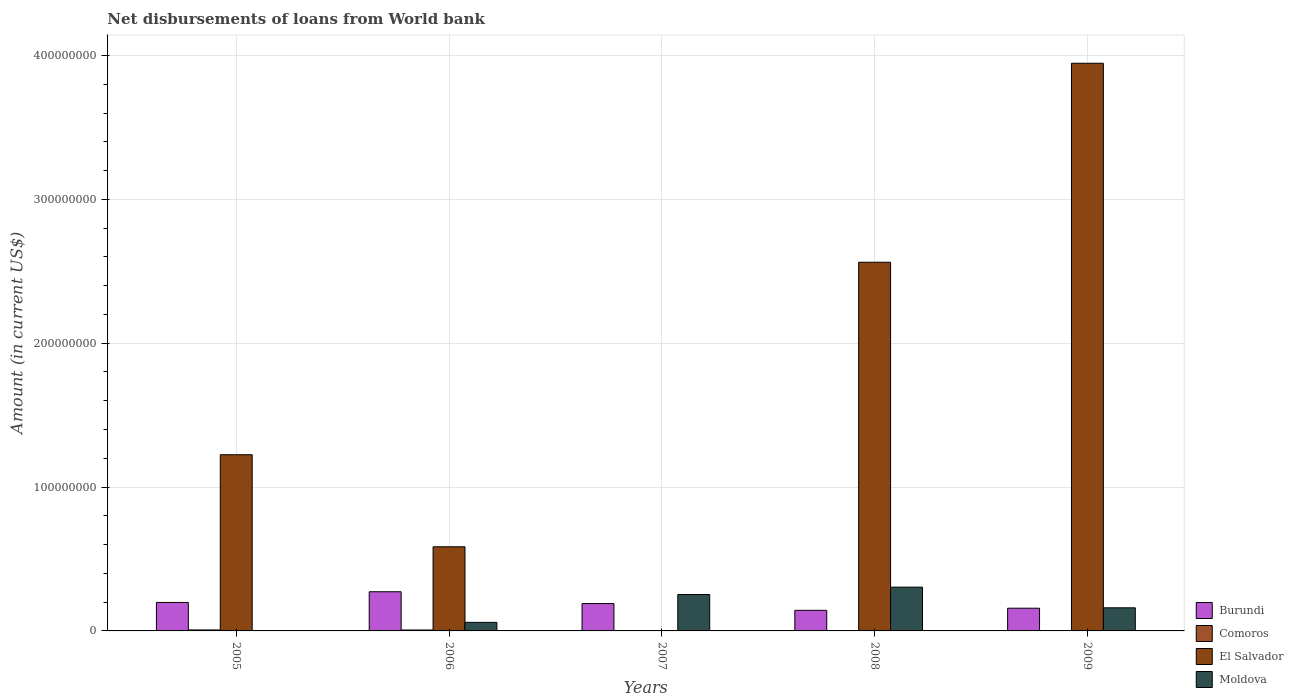How many different coloured bars are there?
Offer a very short reply. 4. Are the number of bars per tick equal to the number of legend labels?
Provide a succinct answer. No. Are the number of bars on each tick of the X-axis equal?
Provide a succinct answer. No. How many bars are there on the 3rd tick from the left?
Your answer should be compact. 2. How many bars are there on the 1st tick from the right?
Ensure brevity in your answer.  3. What is the amount of loan disbursed from World Bank in Comoros in 2006?
Provide a short and direct response. 6.45e+05. Across all years, what is the maximum amount of loan disbursed from World Bank in Comoros?
Offer a very short reply. 6.81e+05. What is the total amount of loan disbursed from World Bank in Comoros in the graph?
Offer a very short reply. 1.33e+06. What is the difference between the amount of loan disbursed from World Bank in Burundi in 2008 and that in 2009?
Your answer should be very brief. -1.48e+06. What is the difference between the amount of loan disbursed from World Bank in Moldova in 2008 and the amount of loan disbursed from World Bank in Burundi in 2007?
Give a very brief answer. 1.14e+07. What is the average amount of loan disbursed from World Bank in Burundi per year?
Keep it short and to the point. 1.92e+07. In the year 2006, what is the difference between the amount of loan disbursed from World Bank in El Salvador and amount of loan disbursed from World Bank in Burundi?
Provide a short and direct response. 3.13e+07. What is the ratio of the amount of loan disbursed from World Bank in Burundi in 2008 to that in 2009?
Provide a short and direct response. 0.91. Is the amount of loan disbursed from World Bank in Burundi in 2008 less than that in 2009?
Your response must be concise. Yes. What is the difference between the highest and the second highest amount of loan disbursed from World Bank in Moldova?
Keep it short and to the point. 5.12e+06. What is the difference between the highest and the lowest amount of loan disbursed from World Bank in Comoros?
Keep it short and to the point. 6.81e+05. Is it the case that in every year, the sum of the amount of loan disbursed from World Bank in El Salvador and amount of loan disbursed from World Bank in Comoros is greater than the sum of amount of loan disbursed from World Bank in Burundi and amount of loan disbursed from World Bank in Moldova?
Offer a terse response. No. Is it the case that in every year, the sum of the amount of loan disbursed from World Bank in Comoros and amount of loan disbursed from World Bank in Burundi is greater than the amount of loan disbursed from World Bank in El Salvador?
Make the answer very short. No. How many bars are there?
Ensure brevity in your answer.  15. Are all the bars in the graph horizontal?
Make the answer very short. No. What is the difference between two consecutive major ticks on the Y-axis?
Make the answer very short. 1.00e+08. Where does the legend appear in the graph?
Ensure brevity in your answer.  Bottom right. What is the title of the graph?
Keep it short and to the point. Net disbursements of loans from World bank. Does "Sweden" appear as one of the legend labels in the graph?
Your answer should be very brief. No. What is the label or title of the Y-axis?
Provide a succinct answer. Amount (in current US$). What is the Amount (in current US$) in Burundi in 2005?
Give a very brief answer. 1.98e+07. What is the Amount (in current US$) of Comoros in 2005?
Your answer should be compact. 6.81e+05. What is the Amount (in current US$) of El Salvador in 2005?
Your response must be concise. 1.22e+08. What is the Amount (in current US$) of Burundi in 2006?
Offer a terse response. 2.72e+07. What is the Amount (in current US$) of Comoros in 2006?
Provide a short and direct response. 6.45e+05. What is the Amount (in current US$) in El Salvador in 2006?
Offer a very short reply. 5.85e+07. What is the Amount (in current US$) in Moldova in 2006?
Ensure brevity in your answer.  5.95e+06. What is the Amount (in current US$) of Burundi in 2007?
Your answer should be compact. 1.90e+07. What is the Amount (in current US$) of El Salvador in 2007?
Give a very brief answer. 0. What is the Amount (in current US$) in Moldova in 2007?
Your response must be concise. 2.53e+07. What is the Amount (in current US$) of Burundi in 2008?
Offer a very short reply. 1.43e+07. What is the Amount (in current US$) of Comoros in 2008?
Offer a terse response. 0. What is the Amount (in current US$) in El Salvador in 2008?
Your response must be concise. 2.56e+08. What is the Amount (in current US$) in Moldova in 2008?
Ensure brevity in your answer.  3.04e+07. What is the Amount (in current US$) of Burundi in 2009?
Make the answer very short. 1.58e+07. What is the Amount (in current US$) of El Salvador in 2009?
Your response must be concise. 3.95e+08. What is the Amount (in current US$) of Moldova in 2009?
Offer a terse response. 1.61e+07. Across all years, what is the maximum Amount (in current US$) of Burundi?
Your answer should be very brief. 2.72e+07. Across all years, what is the maximum Amount (in current US$) of Comoros?
Give a very brief answer. 6.81e+05. Across all years, what is the maximum Amount (in current US$) in El Salvador?
Provide a succinct answer. 3.95e+08. Across all years, what is the maximum Amount (in current US$) in Moldova?
Ensure brevity in your answer.  3.04e+07. Across all years, what is the minimum Amount (in current US$) of Burundi?
Keep it short and to the point. 1.43e+07. Across all years, what is the minimum Amount (in current US$) in Comoros?
Provide a short and direct response. 0. Across all years, what is the minimum Amount (in current US$) of El Salvador?
Keep it short and to the point. 0. What is the total Amount (in current US$) in Burundi in the graph?
Offer a terse response. 9.61e+07. What is the total Amount (in current US$) in Comoros in the graph?
Provide a short and direct response. 1.33e+06. What is the total Amount (in current US$) in El Salvador in the graph?
Ensure brevity in your answer.  8.32e+08. What is the total Amount (in current US$) of Moldova in the graph?
Make the answer very short. 7.78e+07. What is the difference between the Amount (in current US$) of Burundi in 2005 and that in 2006?
Offer a terse response. -7.45e+06. What is the difference between the Amount (in current US$) in Comoros in 2005 and that in 2006?
Give a very brief answer. 3.60e+04. What is the difference between the Amount (in current US$) in El Salvador in 2005 and that in 2006?
Your answer should be compact. 6.40e+07. What is the difference between the Amount (in current US$) in Burundi in 2005 and that in 2007?
Make the answer very short. 7.64e+05. What is the difference between the Amount (in current US$) in Burundi in 2005 and that in 2008?
Your answer should be very brief. 5.48e+06. What is the difference between the Amount (in current US$) in El Salvador in 2005 and that in 2008?
Keep it short and to the point. -1.34e+08. What is the difference between the Amount (in current US$) of Burundi in 2005 and that in 2009?
Offer a very short reply. 4.00e+06. What is the difference between the Amount (in current US$) of El Salvador in 2005 and that in 2009?
Provide a succinct answer. -2.72e+08. What is the difference between the Amount (in current US$) in Burundi in 2006 and that in 2007?
Your answer should be very brief. 8.21e+06. What is the difference between the Amount (in current US$) of Moldova in 2006 and that in 2007?
Keep it short and to the point. -1.94e+07. What is the difference between the Amount (in current US$) in Burundi in 2006 and that in 2008?
Your answer should be compact. 1.29e+07. What is the difference between the Amount (in current US$) in El Salvador in 2006 and that in 2008?
Offer a terse response. -1.98e+08. What is the difference between the Amount (in current US$) in Moldova in 2006 and that in 2008?
Provide a succinct answer. -2.45e+07. What is the difference between the Amount (in current US$) in Burundi in 2006 and that in 2009?
Your answer should be very brief. 1.14e+07. What is the difference between the Amount (in current US$) of El Salvador in 2006 and that in 2009?
Your answer should be very brief. -3.36e+08. What is the difference between the Amount (in current US$) of Moldova in 2006 and that in 2009?
Give a very brief answer. -1.01e+07. What is the difference between the Amount (in current US$) of Burundi in 2007 and that in 2008?
Offer a terse response. 4.72e+06. What is the difference between the Amount (in current US$) of Moldova in 2007 and that in 2008?
Your response must be concise. -5.12e+06. What is the difference between the Amount (in current US$) of Burundi in 2007 and that in 2009?
Provide a short and direct response. 3.24e+06. What is the difference between the Amount (in current US$) of Moldova in 2007 and that in 2009?
Make the answer very short. 9.24e+06. What is the difference between the Amount (in current US$) in Burundi in 2008 and that in 2009?
Offer a terse response. -1.48e+06. What is the difference between the Amount (in current US$) of El Salvador in 2008 and that in 2009?
Your answer should be compact. -1.38e+08. What is the difference between the Amount (in current US$) in Moldova in 2008 and that in 2009?
Your answer should be compact. 1.44e+07. What is the difference between the Amount (in current US$) in Burundi in 2005 and the Amount (in current US$) in Comoros in 2006?
Ensure brevity in your answer.  1.91e+07. What is the difference between the Amount (in current US$) in Burundi in 2005 and the Amount (in current US$) in El Salvador in 2006?
Make the answer very short. -3.87e+07. What is the difference between the Amount (in current US$) of Burundi in 2005 and the Amount (in current US$) of Moldova in 2006?
Give a very brief answer. 1.38e+07. What is the difference between the Amount (in current US$) of Comoros in 2005 and the Amount (in current US$) of El Salvador in 2006?
Ensure brevity in your answer.  -5.78e+07. What is the difference between the Amount (in current US$) in Comoros in 2005 and the Amount (in current US$) in Moldova in 2006?
Offer a terse response. -5.27e+06. What is the difference between the Amount (in current US$) of El Salvador in 2005 and the Amount (in current US$) of Moldova in 2006?
Your response must be concise. 1.17e+08. What is the difference between the Amount (in current US$) of Burundi in 2005 and the Amount (in current US$) of Moldova in 2007?
Give a very brief answer. -5.52e+06. What is the difference between the Amount (in current US$) in Comoros in 2005 and the Amount (in current US$) in Moldova in 2007?
Offer a very short reply. -2.46e+07. What is the difference between the Amount (in current US$) of El Salvador in 2005 and the Amount (in current US$) of Moldova in 2007?
Provide a succinct answer. 9.72e+07. What is the difference between the Amount (in current US$) of Burundi in 2005 and the Amount (in current US$) of El Salvador in 2008?
Make the answer very short. -2.36e+08. What is the difference between the Amount (in current US$) of Burundi in 2005 and the Amount (in current US$) of Moldova in 2008?
Provide a short and direct response. -1.06e+07. What is the difference between the Amount (in current US$) of Comoros in 2005 and the Amount (in current US$) of El Salvador in 2008?
Keep it short and to the point. -2.56e+08. What is the difference between the Amount (in current US$) of Comoros in 2005 and the Amount (in current US$) of Moldova in 2008?
Give a very brief answer. -2.97e+07. What is the difference between the Amount (in current US$) of El Salvador in 2005 and the Amount (in current US$) of Moldova in 2008?
Provide a succinct answer. 9.21e+07. What is the difference between the Amount (in current US$) in Burundi in 2005 and the Amount (in current US$) in El Salvador in 2009?
Give a very brief answer. -3.75e+08. What is the difference between the Amount (in current US$) in Burundi in 2005 and the Amount (in current US$) in Moldova in 2009?
Offer a very short reply. 3.72e+06. What is the difference between the Amount (in current US$) in Comoros in 2005 and the Amount (in current US$) in El Salvador in 2009?
Keep it short and to the point. -3.94e+08. What is the difference between the Amount (in current US$) of Comoros in 2005 and the Amount (in current US$) of Moldova in 2009?
Offer a terse response. -1.54e+07. What is the difference between the Amount (in current US$) of El Salvador in 2005 and the Amount (in current US$) of Moldova in 2009?
Ensure brevity in your answer.  1.06e+08. What is the difference between the Amount (in current US$) of Burundi in 2006 and the Amount (in current US$) of Moldova in 2007?
Your answer should be compact. 1.92e+06. What is the difference between the Amount (in current US$) in Comoros in 2006 and the Amount (in current US$) in Moldova in 2007?
Ensure brevity in your answer.  -2.47e+07. What is the difference between the Amount (in current US$) in El Salvador in 2006 and the Amount (in current US$) in Moldova in 2007?
Ensure brevity in your answer.  3.32e+07. What is the difference between the Amount (in current US$) of Burundi in 2006 and the Amount (in current US$) of El Salvador in 2008?
Your response must be concise. -2.29e+08. What is the difference between the Amount (in current US$) of Burundi in 2006 and the Amount (in current US$) of Moldova in 2008?
Offer a very short reply. -3.19e+06. What is the difference between the Amount (in current US$) of Comoros in 2006 and the Amount (in current US$) of El Salvador in 2008?
Your answer should be very brief. -2.56e+08. What is the difference between the Amount (in current US$) of Comoros in 2006 and the Amount (in current US$) of Moldova in 2008?
Ensure brevity in your answer.  -2.98e+07. What is the difference between the Amount (in current US$) of El Salvador in 2006 and the Amount (in current US$) of Moldova in 2008?
Ensure brevity in your answer.  2.81e+07. What is the difference between the Amount (in current US$) of Burundi in 2006 and the Amount (in current US$) of El Salvador in 2009?
Your response must be concise. -3.67e+08. What is the difference between the Amount (in current US$) of Burundi in 2006 and the Amount (in current US$) of Moldova in 2009?
Keep it short and to the point. 1.12e+07. What is the difference between the Amount (in current US$) in Comoros in 2006 and the Amount (in current US$) in El Salvador in 2009?
Keep it short and to the point. -3.94e+08. What is the difference between the Amount (in current US$) of Comoros in 2006 and the Amount (in current US$) of Moldova in 2009?
Your answer should be very brief. -1.54e+07. What is the difference between the Amount (in current US$) of El Salvador in 2006 and the Amount (in current US$) of Moldova in 2009?
Your response must be concise. 4.24e+07. What is the difference between the Amount (in current US$) of Burundi in 2007 and the Amount (in current US$) of El Salvador in 2008?
Ensure brevity in your answer.  -2.37e+08. What is the difference between the Amount (in current US$) of Burundi in 2007 and the Amount (in current US$) of Moldova in 2008?
Provide a succinct answer. -1.14e+07. What is the difference between the Amount (in current US$) of Burundi in 2007 and the Amount (in current US$) of El Salvador in 2009?
Your answer should be very brief. -3.76e+08. What is the difference between the Amount (in current US$) of Burundi in 2007 and the Amount (in current US$) of Moldova in 2009?
Ensure brevity in your answer.  2.96e+06. What is the difference between the Amount (in current US$) in Burundi in 2008 and the Amount (in current US$) in El Salvador in 2009?
Your answer should be compact. -3.80e+08. What is the difference between the Amount (in current US$) of Burundi in 2008 and the Amount (in current US$) of Moldova in 2009?
Your answer should be compact. -1.76e+06. What is the difference between the Amount (in current US$) of El Salvador in 2008 and the Amount (in current US$) of Moldova in 2009?
Your answer should be compact. 2.40e+08. What is the average Amount (in current US$) of Burundi per year?
Ensure brevity in your answer.  1.92e+07. What is the average Amount (in current US$) of Comoros per year?
Your response must be concise. 2.65e+05. What is the average Amount (in current US$) in El Salvador per year?
Offer a very short reply. 1.66e+08. What is the average Amount (in current US$) of Moldova per year?
Keep it short and to the point. 1.56e+07. In the year 2005, what is the difference between the Amount (in current US$) in Burundi and Amount (in current US$) in Comoros?
Provide a succinct answer. 1.91e+07. In the year 2005, what is the difference between the Amount (in current US$) of Burundi and Amount (in current US$) of El Salvador?
Provide a short and direct response. -1.03e+08. In the year 2005, what is the difference between the Amount (in current US$) of Comoros and Amount (in current US$) of El Salvador?
Your answer should be compact. -1.22e+08. In the year 2006, what is the difference between the Amount (in current US$) of Burundi and Amount (in current US$) of Comoros?
Your response must be concise. 2.66e+07. In the year 2006, what is the difference between the Amount (in current US$) of Burundi and Amount (in current US$) of El Salvador?
Make the answer very short. -3.13e+07. In the year 2006, what is the difference between the Amount (in current US$) of Burundi and Amount (in current US$) of Moldova?
Provide a short and direct response. 2.13e+07. In the year 2006, what is the difference between the Amount (in current US$) of Comoros and Amount (in current US$) of El Salvador?
Make the answer very short. -5.78e+07. In the year 2006, what is the difference between the Amount (in current US$) in Comoros and Amount (in current US$) in Moldova?
Offer a terse response. -5.31e+06. In the year 2006, what is the difference between the Amount (in current US$) in El Salvador and Amount (in current US$) in Moldova?
Your response must be concise. 5.25e+07. In the year 2007, what is the difference between the Amount (in current US$) of Burundi and Amount (in current US$) of Moldova?
Make the answer very short. -6.29e+06. In the year 2008, what is the difference between the Amount (in current US$) in Burundi and Amount (in current US$) in El Salvador?
Your response must be concise. -2.42e+08. In the year 2008, what is the difference between the Amount (in current US$) in Burundi and Amount (in current US$) in Moldova?
Offer a terse response. -1.61e+07. In the year 2008, what is the difference between the Amount (in current US$) in El Salvador and Amount (in current US$) in Moldova?
Ensure brevity in your answer.  2.26e+08. In the year 2009, what is the difference between the Amount (in current US$) of Burundi and Amount (in current US$) of El Salvador?
Provide a succinct answer. -3.79e+08. In the year 2009, what is the difference between the Amount (in current US$) in Burundi and Amount (in current US$) in Moldova?
Offer a terse response. -2.80e+05. In the year 2009, what is the difference between the Amount (in current US$) in El Salvador and Amount (in current US$) in Moldova?
Provide a short and direct response. 3.79e+08. What is the ratio of the Amount (in current US$) of Burundi in 2005 to that in 2006?
Your answer should be compact. 0.73. What is the ratio of the Amount (in current US$) of Comoros in 2005 to that in 2006?
Keep it short and to the point. 1.06. What is the ratio of the Amount (in current US$) in El Salvador in 2005 to that in 2006?
Provide a short and direct response. 2.09. What is the ratio of the Amount (in current US$) in Burundi in 2005 to that in 2007?
Your response must be concise. 1.04. What is the ratio of the Amount (in current US$) in Burundi in 2005 to that in 2008?
Your response must be concise. 1.38. What is the ratio of the Amount (in current US$) of El Salvador in 2005 to that in 2008?
Your response must be concise. 0.48. What is the ratio of the Amount (in current US$) in Burundi in 2005 to that in 2009?
Offer a terse response. 1.25. What is the ratio of the Amount (in current US$) of El Salvador in 2005 to that in 2009?
Your answer should be very brief. 0.31. What is the ratio of the Amount (in current US$) in Burundi in 2006 to that in 2007?
Your answer should be compact. 1.43. What is the ratio of the Amount (in current US$) of Moldova in 2006 to that in 2007?
Offer a very short reply. 0.24. What is the ratio of the Amount (in current US$) of Burundi in 2006 to that in 2008?
Provide a short and direct response. 1.9. What is the ratio of the Amount (in current US$) of El Salvador in 2006 to that in 2008?
Your answer should be compact. 0.23. What is the ratio of the Amount (in current US$) in Moldova in 2006 to that in 2008?
Your answer should be compact. 0.2. What is the ratio of the Amount (in current US$) in Burundi in 2006 to that in 2009?
Your answer should be very brief. 1.73. What is the ratio of the Amount (in current US$) in El Salvador in 2006 to that in 2009?
Provide a succinct answer. 0.15. What is the ratio of the Amount (in current US$) of Moldova in 2006 to that in 2009?
Provide a short and direct response. 0.37. What is the ratio of the Amount (in current US$) of Burundi in 2007 to that in 2008?
Offer a terse response. 1.33. What is the ratio of the Amount (in current US$) in Moldova in 2007 to that in 2008?
Your response must be concise. 0.83. What is the ratio of the Amount (in current US$) in Burundi in 2007 to that in 2009?
Offer a very short reply. 1.2. What is the ratio of the Amount (in current US$) in Moldova in 2007 to that in 2009?
Your response must be concise. 1.58. What is the ratio of the Amount (in current US$) in Burundi in 2008 to that in 2009?
Your answer should be compact. 0.91. What is the ratio of the Amount (in current US$) in El Salvador in 2008 to that in 2009?
Give a very brief answer. 0.65. What is the ratio of the Amount (in current US$) of Moldova in 2008 to that in 2009?
Give a very brief answer. 1.89. What is the difference between the highest and the second highest Amount (in current US$) of Burundi?
Your answer should be compact. 7.45e+06. What is the difference between the highest and the second highest Amount (in current US$) in El Salvador?
Your response must be concise. 1.38e+08. What is the difference between the highest and the second highest Amount (in current US$) in Moldova?
Ensure brevity in your answer.  5.12e+06. What is the difference between the highest and the lowest Amount (in current US$) of Burundi?
Make the answer very short. 1.29e+07. What is the difference between the highest and the lowest Amount (in current US$) in Comoros?
Keep it short and to the point. 6.81e+05. What is the difference between the highest and the lowest Amount (in current US$) in El Salvador?
Give a very brief answer. 3.95e+08. What is the difference between the highest and the lowest Amount (in current US$) in Moldova?
Ensure brevity in your answer.  3.04e+07. 